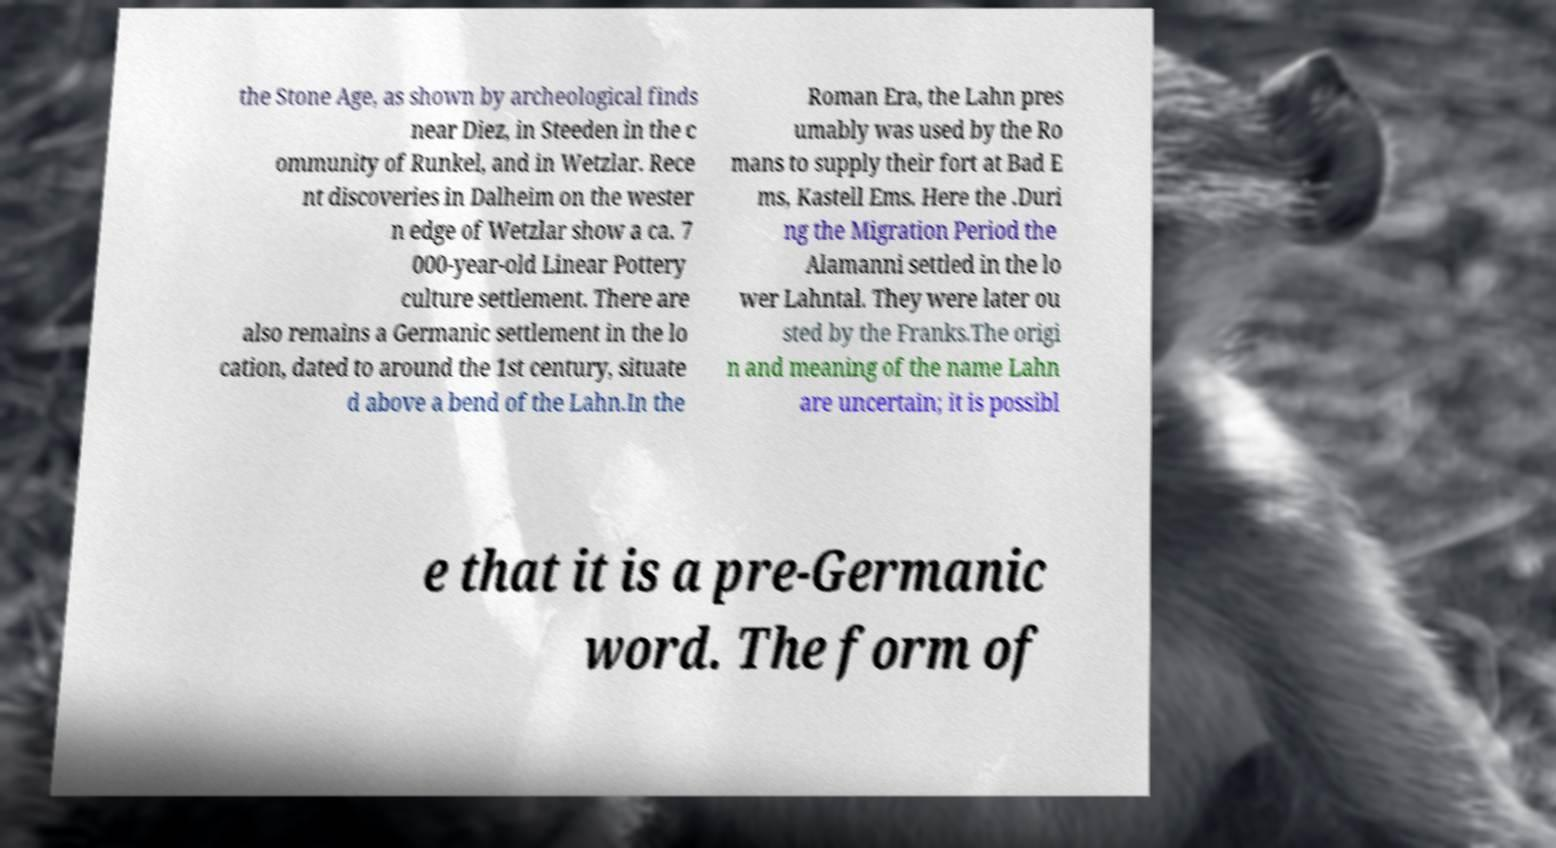Can you read and provide the text displayed in the image?This photo seems to have some interesting text. Can you extract and type it out for me? the Stone Age, as shown by archeological finds near Diez, in Steeden in the c ommunity of Runkel, and in Wetzlar. Rece nt discoveries in Dalheim on the wester n edge of Wetzlar show a ca. 7 000-year-old Linear Pottery culture settlement. There are also remains a Germanic settlement in the lo cation, dated to around the 1st century, situate d above a bend of the Lahn.In the Roman Era, the Lahn pres umably was used by the Ro mans to supply their fort at Bad E ms, Kastell Ems. Here the .Duri ng the Migration Period the Alamanni settled in the lo wer Lahntal. They were later ou sted by the Franks.The origi n and meaning of the name Lahn are uncertain; it is possibl e that it is a pre-Germanic word. The form of 